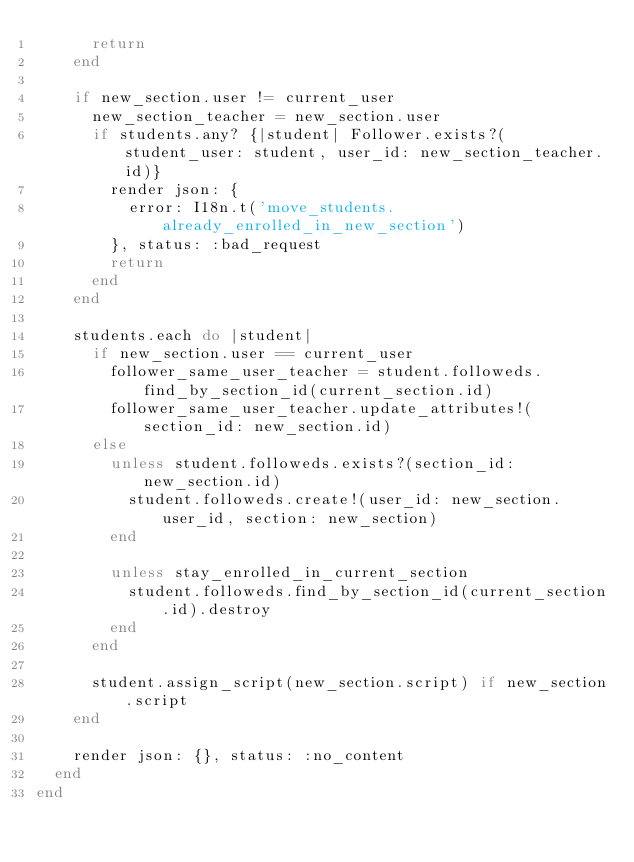Convert code to text. <code><loc_0><loc_0><loc_500><loc_500><_Ruby_>      return
    end

    if new_section.user != current_user
      new_section_teacher = new_section.user
      if students.any? {|student| Follower.exists?(student_user: student, user_id: new_section_teacher.id)}
        render json: {
          error: I18n.t('move_students.already_enrolled_in_new_section')
        }, status: :bad_request
        return
      end
    end

    students.each do |student|
      if new_section.user == current_user
        follower_same_user_teacher = student.followeds.find_by_section_id(current_section.id)
        follower_same_user_teacher.update_attributes!(section_id: new_section.id)
      else
        unless student.followeds.exists?(section_id: new_section.id)
          student.followeds.create!(user_id: new_section.user_id, section: new_section)
        end

        unless stay_enrolled_in_current_section
          student.followeds.find_by_section_id(current_section.id).destroy
        end
      end

      student.assign_script(new_section.script) if new_section.script
    end

    render json: {}, status: :no_content
  end
end
</code> 